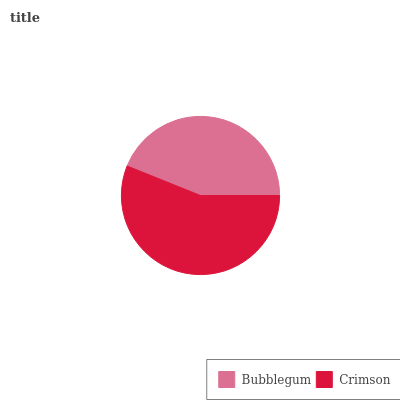Is Bubblegum the minimum?
Answer yes or no. Yes. Is Crimson the maximum?
Answer yes or no. Yes. Is Crimson the minimum?
Answer yes or no. No. Is Crimson greater than Bubblegum?
Answer yes or no. Yes. Is Bubblegum less than Crimson?
Answer yes or no. Yes. Is Bubblegum greater than Crimson?
Answer yes or no. No. Is Crimson less than Bubblegum?
Answer yes or no. No. Is Crimson the high median?
Answer yes or no. Yes. Is Bubblegum the low median?
Answer yes or no. Yes. Is Bubblegum the high median?
Answer yes or no. No. Is Crimson the low median?
Answer yes or no. No. 